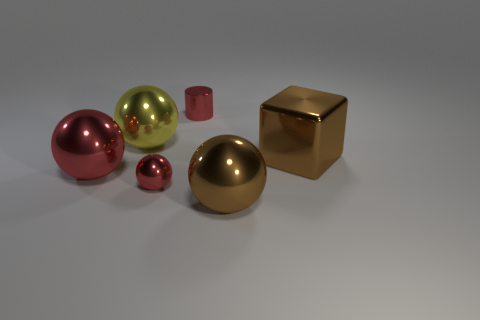Add 2 brown blocks. How many objects exist? 8 Subtract all tiny balls. How many balls are left? 3 Subtract all cubes. How many objects are left? 5 Subtract all red balls. How many balls are left? 2 Subtract 1 spheres. How many spheres are left? 3 Add 2 large objects. How many large objects exist? 6 Subtract 1 brown balls. How many objects are left? 5 Subtract all purple balls. Subtract all cyan cylinders. How many balls are left? 4 Subtract all green spheres. How many yellow blocks are left? 0 Subtract all big brown shiny things. Subtract all big brown cubes. How many objects are left? 3 